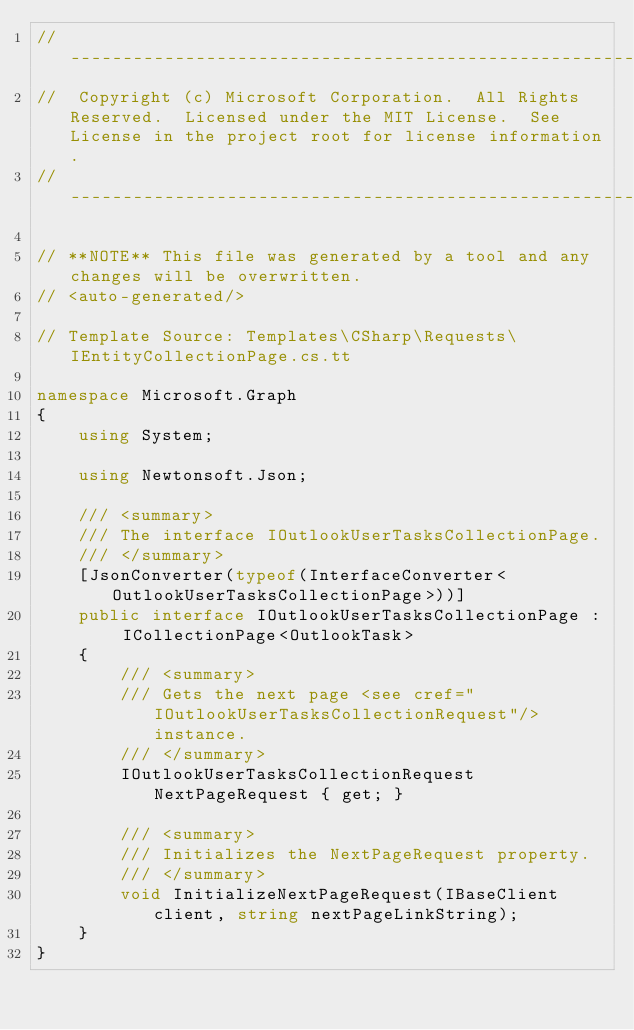Convert code to text. <code><loc_0><loc_0><loc_500><loc_500><_C#_>// ------------------------------------------------------------------------------
//  Copyright (c) Microsoft Corporation.  All Rights Reserved.  Licensed under the MIT License.  See License in the project root for license information.
// ------------------------------------------------------------------------------

// **NOTE** This file was generated by a tool and any changes will be overwritten.
// <auto-generated/>

// Template Source: Templates\CSharp\Requests\IEntityCollectionPage.cs.tt

namespace Microsoft.Graph
{
    using System;

    using Newtonsoft.Json;

    /// <summary>
    /// The interface IOutlookUserTasksCollectionPage.
    /// </summary>
    [JsonConverter(typeof(InterfaceConverter<OutlookUserTasksCollectionPage>))]
    public interface IOutlookUserTasksCollectionPage : ICollectionPage<OutlookTask>
    {
        /// <summary>
        /// Gets the next page <see cref="IOutlookUserTasksCollectionRequest"/> instance.
        /// </summary>
        IOutlookUserTasksCollectionRequest NextPageRequest { get; }

        /// <summary>
        /// Initializes the NextPageRequest property.
        /// </summary>
        void InitializeNextPageRequest(IBaseClient client, string nextPageLinkString);
    }
}
</code> 